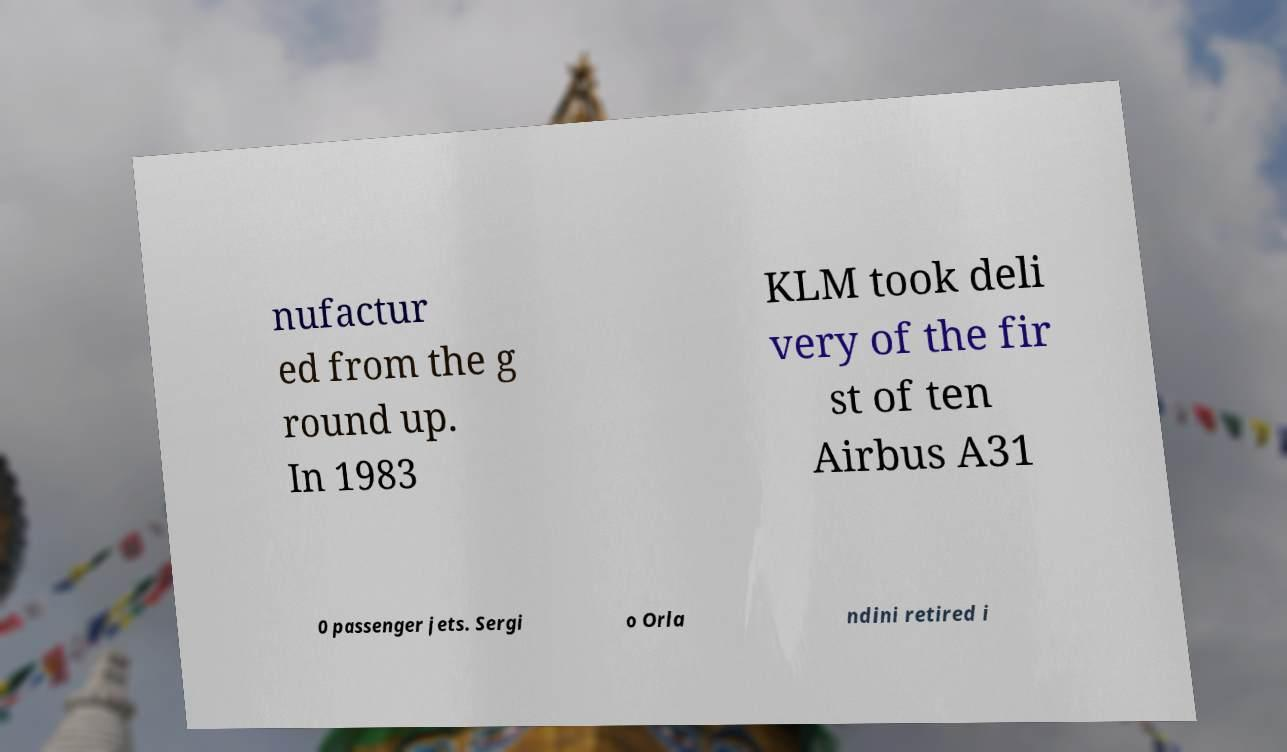Please identify and transcribe the text found in this image. nufactur ed from the g round up. In 1983 KLM took deli very of the fir st of ten Airbus A31 0 passenger jets. Sergi o Orla ndini retired i 